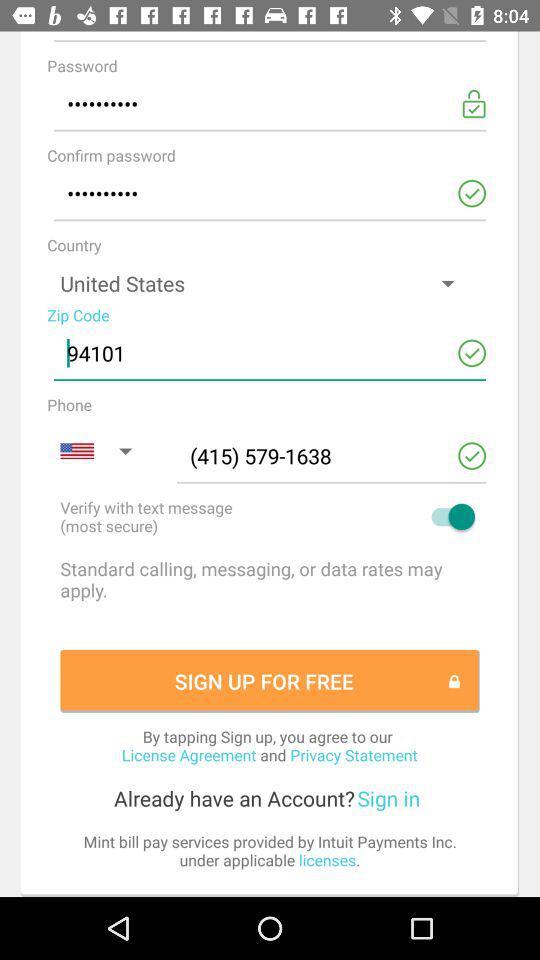Which country is selected in the "Country" section? The selected country is the United States. 